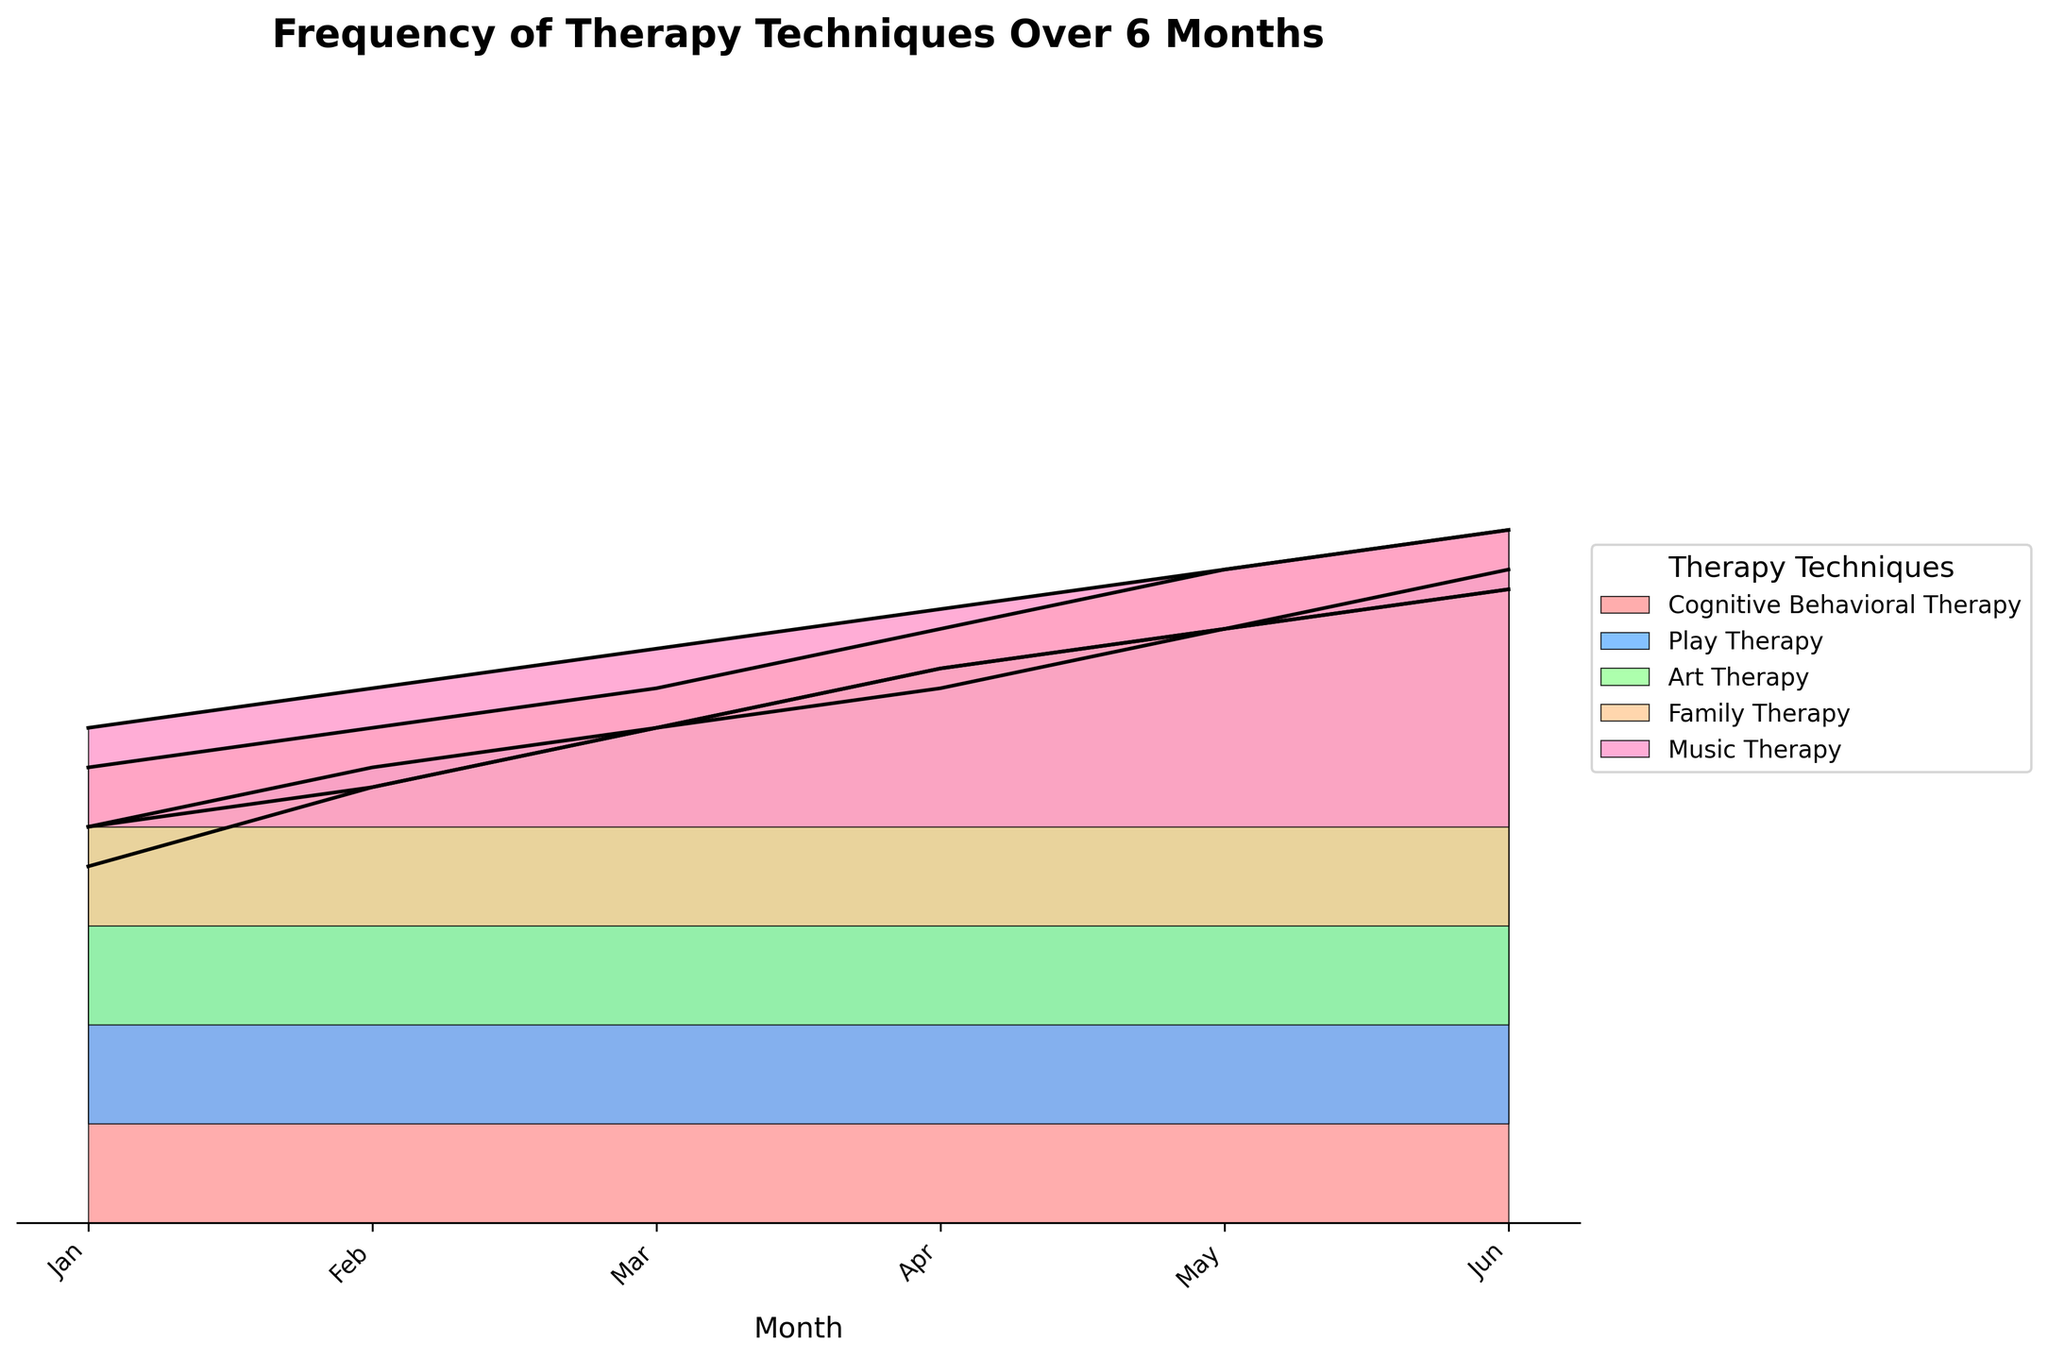**Q1**: What is the title of the plot? The title is usually the text displayed at the top of the figure. In this case, it reads: "Frequency of Therapy Techniques Over 6 Months".
Answer: Frequency of Therapy Techniques Over 6 Months **Q2**: Which therapy technique has the highest frequency in June? Look at the highest values (frequencies) in the month of June across different therapy techniques. Cognitive Behavioral Therapy shows the highest value (32), as indicated by the peak height in June.
Answer: Cognitive Behavioral Therapy **Q3**: How many months are depicted in the plot? The x-axis labels represent months, starting from January and ending in June. Counting these labels gives us the number of months depicted.
Answer: Six **Q4**: Which technique shows the least frequency in January? Observe the peaks in January for each technique. Music Therapy has the lowest peak at a frequency of 5.
Answer: Music Therapy **Q5**: What was the increase in frequency for Play Therapy from January to June? Check the frequencies of Play Therapy in January (15) and in June (28), then subtract the January frequency from the June frequency: 28 - 15 = 13.
Answer: 13 **Q6**: Which month shows the highest combined frequency for all techniques? Add the frequencies for all techniques for each month, and compare to find the highest combined frequency month. For June: 32 (CBT) + 28 (Play) + 22 (Art) + 20 (Family) + 15 (Music) = 117, which is the highest.
Answer: June **Q7**: Between Cognitive Behavioral Therapy and Art Therapy, which one has a higher frequency in April? Compare the frequencies of both techniques in April. Cognitive Behavioral Therapy has a frequency of 28 while Art Therapy has 18.
Answer: Cognitive Behavioral Therapy **Q8**: Does the frequency of Family Therapy ever surpass the frequency of Play Therapy in any month? Compare the frequency of Family Therapy and Play Therapy for each month. Play Therapy always has higher frequency values than Family Therapy in all months depicted.
Answer: No **Q9**: Is there any therapy technique that shows a decreasing trend from January to June? Check the trend for each technique. All therapy techniques, including Cognitive Behavioral Therapy, Play Therapy, Art Therapy, Family Therapy, and Music Therapy, show increasing trends over the months from January to June.
Answer: No **Q10**: How does the frequency of Music Therapy in May compare to the frequency of Art Therapy in March? Observe the frequency values for both. Music Therapy in May has a frequency of 13, while Art Therapy in March has 15. Hence, Art Therapy in March is higher.
Answer: Art Therapy in March is higher 